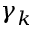Convert formula to latex. <formula><loc_0><loc_0><loc_500><loc_500>\gamma _ { k }</formula> 